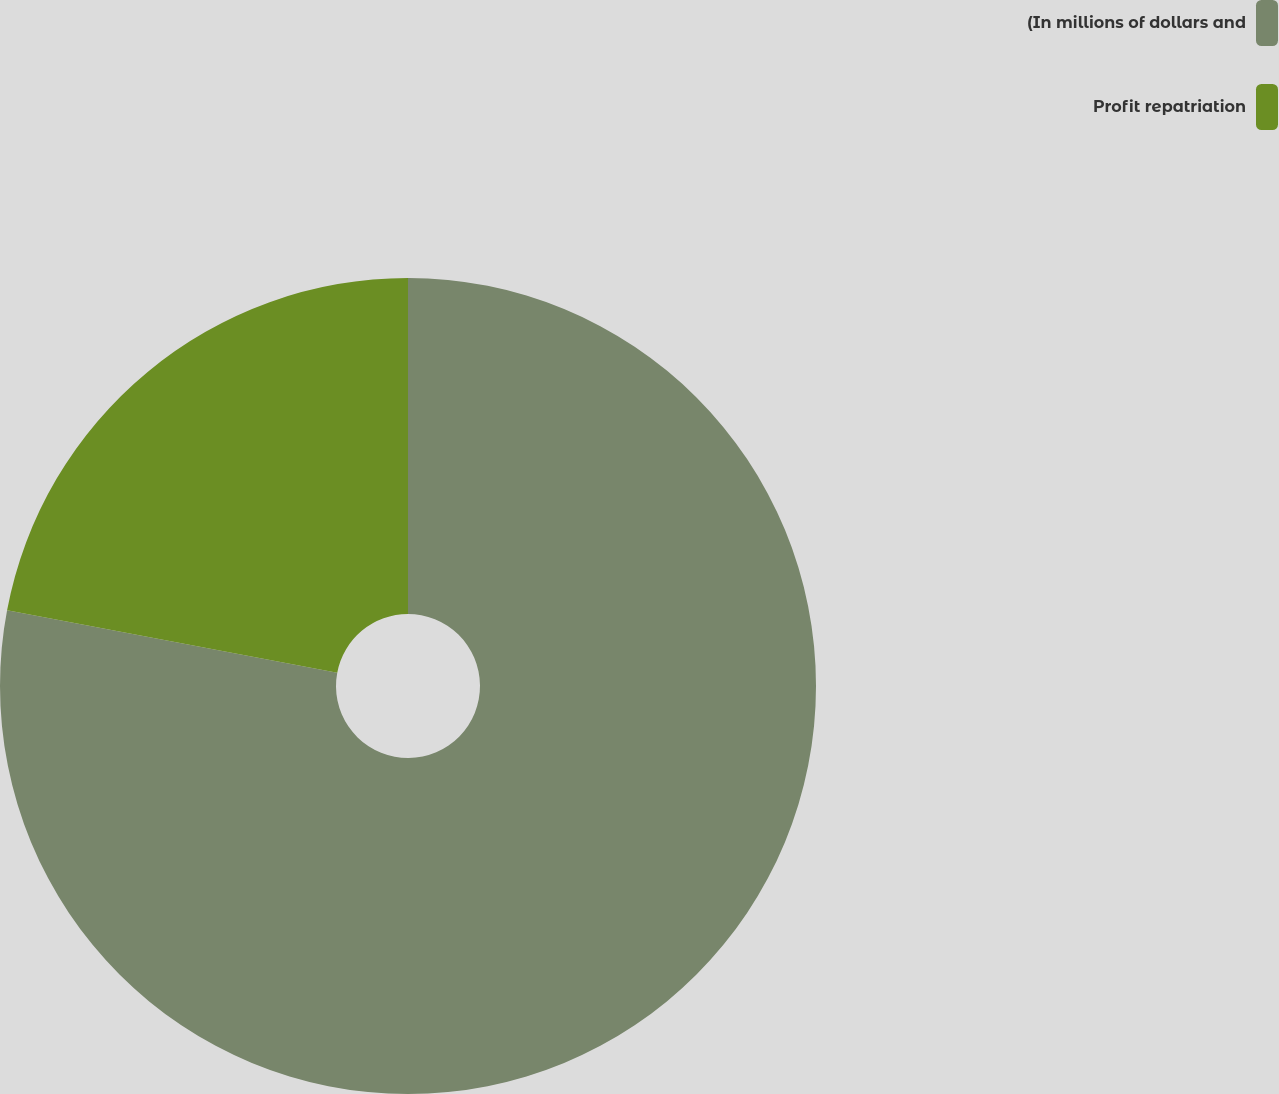Convert chart. <chart><loc_0><loc_0><loc_500><loc_500><pie_chart><fcel>(In millions of dollars and<fcel>Profit repatriation<nl><fcel>77.97%<fcel>22.03%<nl></chart> 